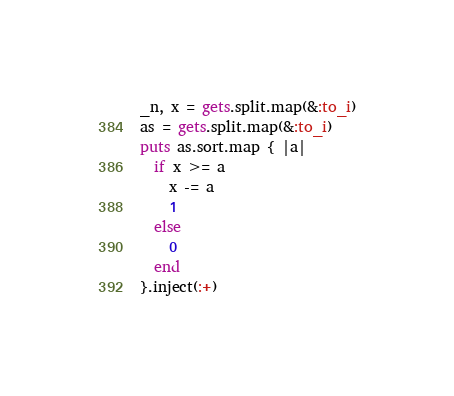<code> <loc_0><loc_0><loc_500><loc_500><_Ruby_>_n, x = gets.split.map(&:to_i)
as = gets.split.map(&:to_i)
puts as.sort.map { |a|
  if x >= a
    x -= a
    1
  else
    0
  end
}.inject(:+)
</code> 